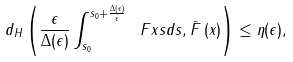Convert formula to latex. <formula><loc_0><loc_0><loc_500><loc_500>d _ { H } \left ( \frac { \epsilon } { \Delta ( \epsilon ) } \int _ { s _ { 0 } } ^ { s _ { 0 } + \frac { \Delta \left ( \epsilon \right ) } { \epsilon } } \ F x s d s , \bar { F } \left ( x \right ) \right ) \leq \eta ( \epsilon ) ,</formula> 